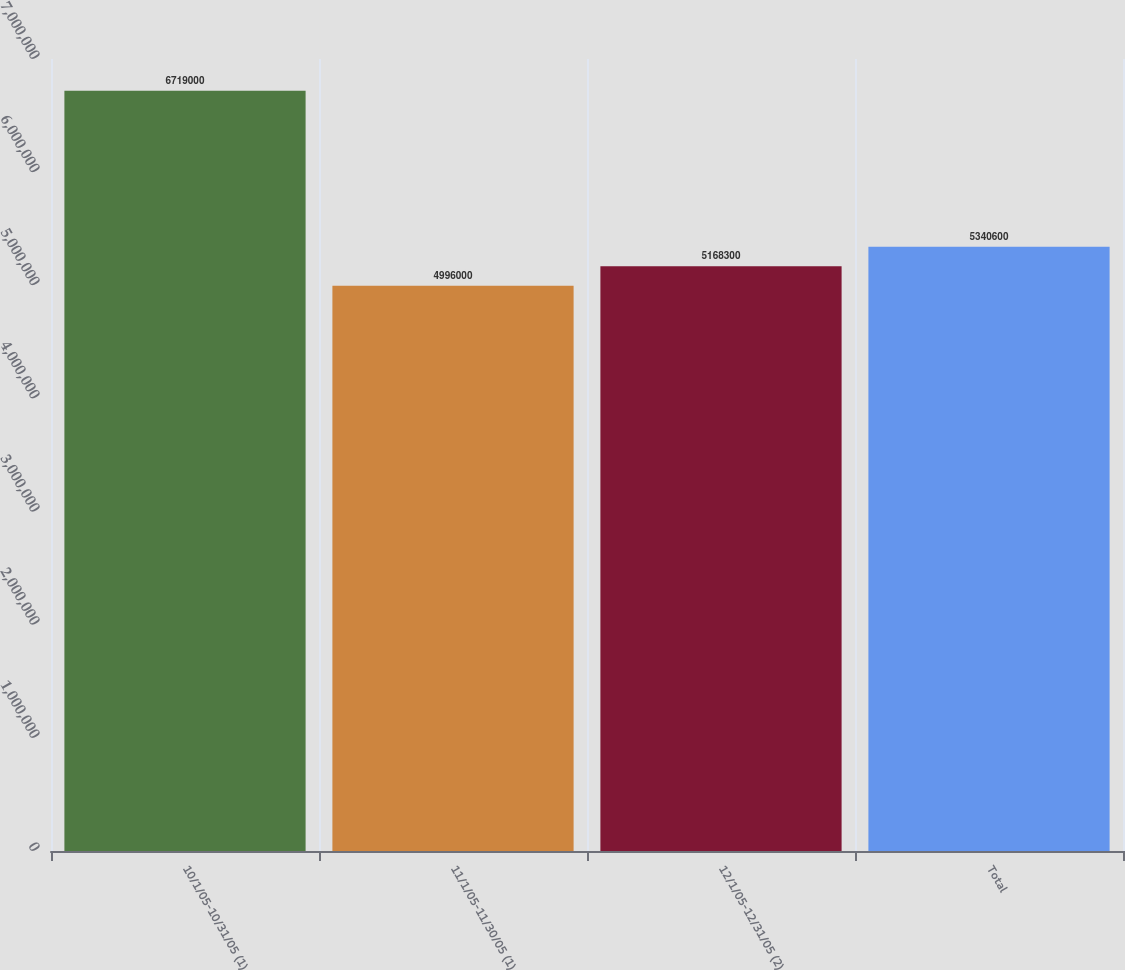Convert chart to OTSL. <chart><loc_0><loc_0><loc_500><loc_500><bar_chart><fcel>10/1/05-10/31/05 (1)<fcel>11/1/05-11/30/05 (1)<fcel>12/1/05-12/31/05 (2)<fcel>Total<nl><fcel>6.719e+06<fcel>4.996e+06<fcel>5.1683e+06<fcel>5.3406e+06<nl></chart> 